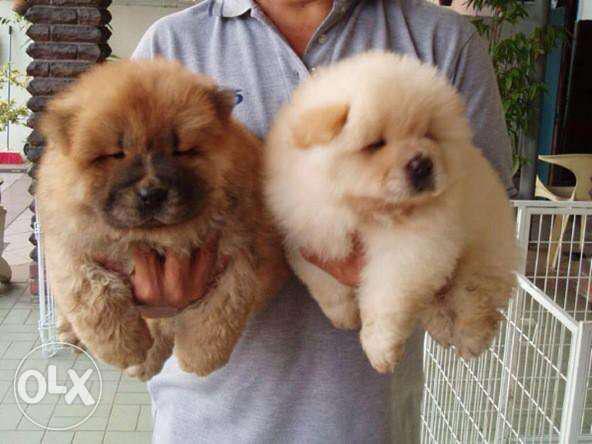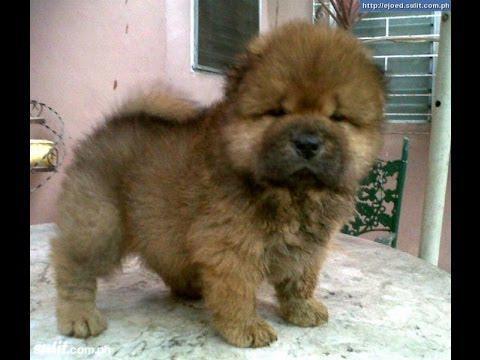The first image is the image on the left, the second image is the image on the right. For the images displayed, is the sentence "There are at least two dogs in the image on the left." factually correct? Answer yes or no. Yes. The first image is the image on the left, the second image is the image on the right. Assess this claim about the two images: "There are no less than three dogs". Correct or not? Answer yes or no. Yes. 